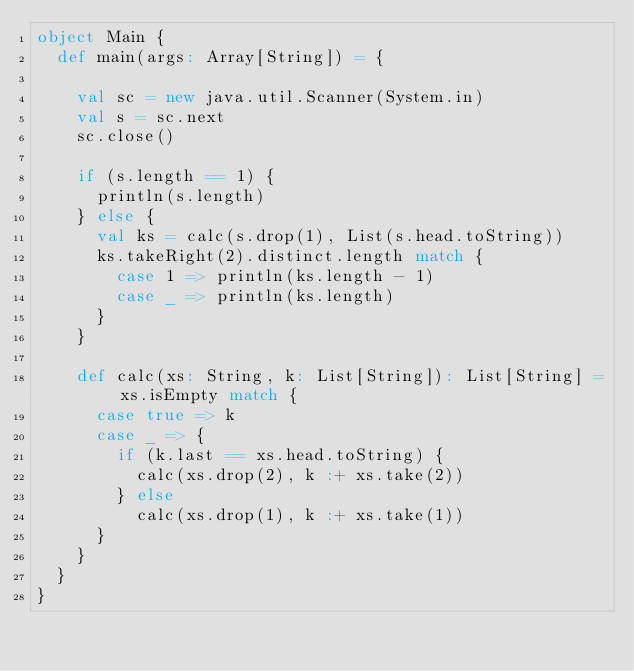<code> <loc_0><loc_0><loc_500><loc_500><_Scala_>object Main {
  def main(args: Array[String]) = {

    val sc = new java.util.Scanner(System.in)
    val s = sc.next
    sc.close()

    if (s.length == 1) {
      println(s.length)
    } else {
      val ks = calc(s.drop(1), List(s.head.toString))
      ks.takeRight(2).distinct.length match {
        case 1 => println(ks.length - 1)
        case _ => println(ks.length)
      }
    }

    def calc(xs: String, k: List[String]): List[String] = xs.isEmpty match {
      case true => k
      case _ => {
        if (k.last == xs.head.toString) {
          calc(xs.drop(2), k :+ xs.take(2))
        } else
          calc(xs.drop(1), k :+ xs.take(1))
      }
    }
  }
}</code> 